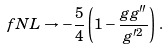<formula> <loc_0><loc_0><loc_500><loc_500>\ f N L \to - \frac { 5 } { 4 } \left ( 1 - \frac { g g ^ { \prime \prime } } { g ^ { \prime 2 } } \right ) \, .</formula> 